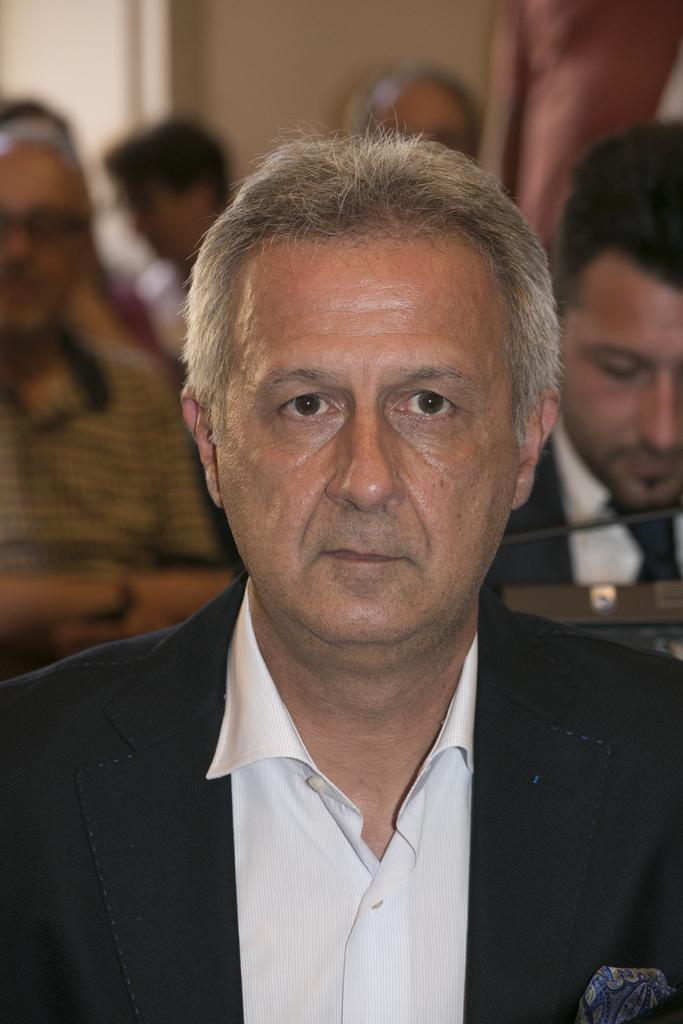Can you describe this image briefly? In this image, we can see persons wearing clothes. In the background, image is blurred. 